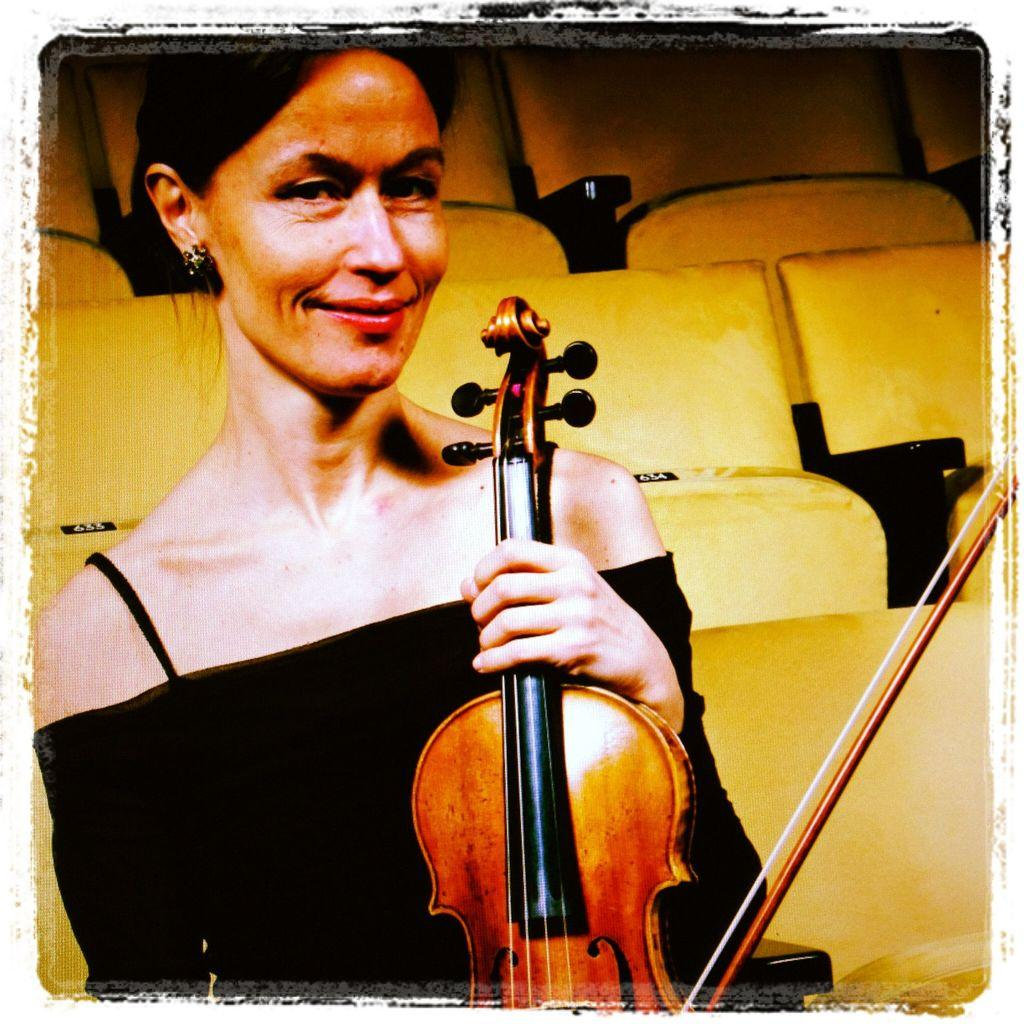Who is the main subject in the image? There is a woman in the image. What is the woman doing in the image? The woman is sitting in a chair. What object is the woman holding in the image? The woman is holding a violin. What type of cherry is the woman eating in the image? There is no cherry present in the image, and the woman is not eating anything. 